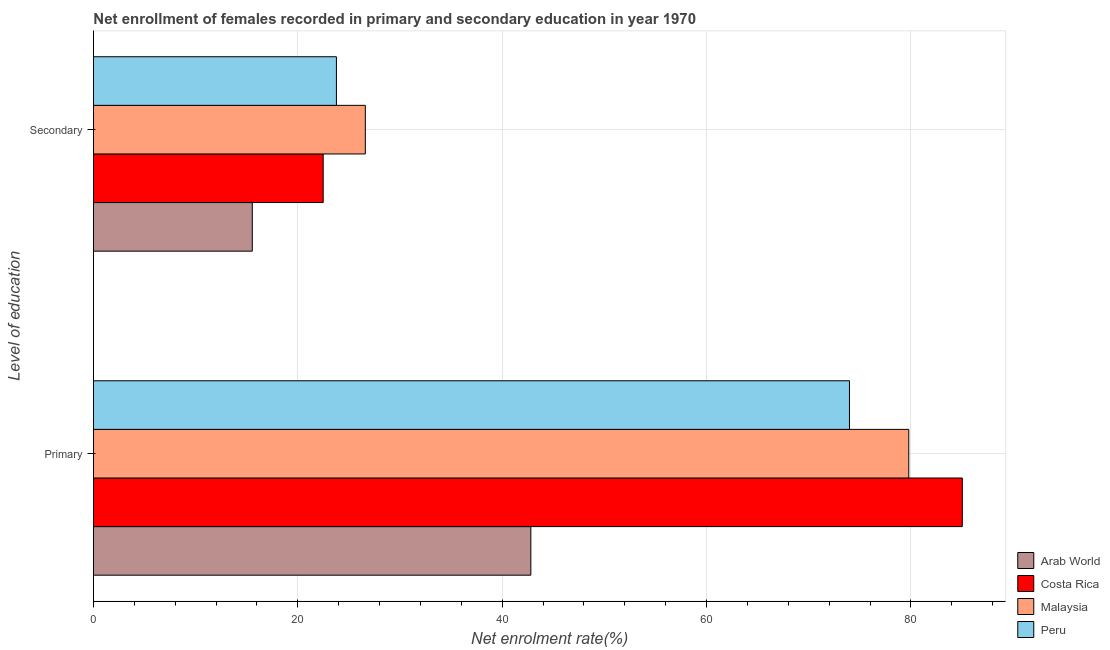Are the number of bars per tick equal to the number of legend labels?
Your response must be concise. Yes. How many bars are there on the 1st tick from the top?
Provide a short and direct response. 4. What is the label of the 2nd group of bars from the top?
Offer a very short reply. Primary. What is the enrollment rate in primary education in Peru?
Your answer should be very brief. 73.99. Across all countries, what is the maximum enrollment rate in secondary education?
Your answer should be very brief. 26.61. Across all countries, what is the minimum enrollment rate in primary education?
Your answer should be very brief. 42.8. In which country was the enrollment rate in primary education minimum?
Ensure brevity in your answer.  Arab World. What is the total enrollment rate in primary education in the graph?
Provide a short and direct response. 281.61. What is the difference between the enrollment rate in secondary education in Malaysia and that in Arab World?
Your response must be concise. 11.06. What is the difference between the enrollment rate in secondary education in Arab World and the enrollment rate in primary education in Peru?
Provide a short and direct response. -58.44. What is the average enrollment rate in primary education per country?
Offer a terse response. 70.4. What is the difference between the enrollment rate in primary education and enrollment rate in secondary education in Malaysia?
Offer a very short reply. 53.18. In how many countries, is the enrollment rate in secondary education greater than 60 %?
Give a very brief answer. 0. What is the ratio of the enrollment rate in secondary education in Peru to that in Arab World?
Your response must be concise. 1.53. What does the 2nd bar from the bottom in Primary represents?
Provide a succinct answer. Costa Rica. How many countries are there in the graph?
Your answer should be compact. 4. Does the graph contain any zero values?
Your answer should be very brief. No. Does the graph contain grids?
Provide a succinct answer. Yes. Where does the legend appear in the graph?
Ensure brevity in your answer.  Bottom right. How many legend labels are there?
Make the answer very short. 4. How are the legend labels stacked?
Your response must be concise. Vertical. What is the title of the graph?
Offer a terse response. Net enrollment of females recorded in primary and secondary education in year 1970. What is the label or title of the X-axis?
Provide a succinct answer. Net enrolment rate(%). What is the label or title of the Y-axis?
Ensure brevity in your answer.  Level of education. What is the Net enrolment rate(%) of Arab World in Primary?
Give a very brief answer. 42.8. What is the Net enrolment rate(%) of Costa Rica in Primary?
Your answer should be compact. 85.03. What is the Net enrolment rate(%) in Malaysia in Primary?
Offer a very short reply. 79.79. What is the Net enrolment rate(%) of Peru in Primary?
Make the answer very short. 73.99. What is the Net enrolment rate(%) of Arab World in Secondary?
Ensure brevity in your answer.  15.54. What is the Net enrolment rate(%) in Costa Rica in Secondary?
Keep it short and to the point. 22.48. What is the Net enrolment rate(%) in Malaysia in Secondary?
Your answer should be compact. 26.61. What is the Net enrolment rate(%) of Peru in Secondary?
Provide a short and direct response. 23.78. Across all Level of education, what is the maximum Net enrolment rate(%) in Arab World?
Ensure brevity in your answer.  42.8. Across all Level of education, what is the maximum Net enrolment rate(%) in Costa Rica?
Your response must be concise. 85.03. Across all Level of education, what is the maximum Net enrolment rate(%) in Malaysia?
Offer a very short reply. 79.79. Across all Level of education, what is the maximum Net enrolment rate(%) in Peru?
Your answer should be very brief. 73.99. Across all Level of education, what is the minimum Net enrolment rate(%) in Arab World?
Give a very brief answer. 15.54. Across all Level of education, what is the minimum Net enrolment rate(%) in Costa Rica?
Ensure brevity in your answer.  22.48. Across all Level of education, what is the minimum Net enrolment rate(%) in Malaysia?
Ensure brevity in your answer.  26.61. Across all Level of education, what is the minimum Net enrolment rate(%) of Peru?
Provide a short and direct response. 23.78. What is the total Net enrolment rate(%) in Arab World in the graph?
Provide a short and direct response. 58.35. What is the total Net enrolment rate(%) in Costa Rica in the graph?
Ensure brevity in your answer.  107.51. What is the total Net enrolment rate(%) of Malaysia in the graph?
Provide a succinct answer. 106.4. What is the total Net enrolment rate(%) of Peru in the graph?
Provide a succinct answer. 97.77. What is the difference between the Net enrolment rate(%) in Arab World in Primary and that in Secondary?
Keep it short and to the point. 27.26. What is the difference between the Net enrolment rate(%) in Costa Rica in Primary and that in Secondary?
Make the answer very short. 62.55. What is the difference between the Net enrolment rate(%) in Malaysia in Primary and that in Secondary?
Your response must be concise. 53.18. What is the difference between the Net enrolment rate(%) of Peru in Primary and that in Secondary?
Offer a very short reply. 50.21. What is the difference between the Net enrolment rate(%) of Arab World in Primary and the Net enrolment rate(%) of Costa Rica in Secondary?
Ensure brevity in your answer.  20.32. What is the difference between the Net enrolment rate(%) of Arab World in Primary and the Net enrolment rate(%) of Malaysia in Secondary?
Provide a succinct answer. 16.2. What is the difference between the Net enrolment rate(%) in Arab World in Primary and the Net enrolment rate(%) in Peru in Secondary?
Provide a succinct answer. 19.03. What is the difference between the Net enrolment rate(%) of Costa Rica in Primary and the Net enrolment rate(%) of Malaysia in Secondary?
Make the answer very short. 58.42. What is the difference between the Net enrolment rate(%) of Costa Rica in Primary and the Net enrolment rate(%) of Peru in Secondary?
Your answer should be very brief. 61.25. What is the difference between the Net enrolment rate(%) in Malaysia in Primary and the Net enrolment rate(%) in Peru in Secondary?
Keep it short and to the point. 56.01. What is the average Net enrolment rate(%) of Arab World per Level of education?
Your answer should be very brief. 29.17. What is the average Net enrolment rate(%) of Costa Rica per Level of education?
Offer a very short reply. 53.76. What is the average Net enrolment rate(%) of Malaysia per Level of education?
Make the answer very short. 53.2. What is the average Net enrolment rate(%) in Peru per Level of education?
Give a very brief answer. 48.88. What is the difference between the Net enrolment rate(%) of Arab World and Net enrolment rate(%) of Costa Rica in Primary?
Give a very brief answer. -42.23. What is the difference between the Net enrolment rate(%) in Arab World and Net enrolment rate(%) in Malaysia in Primary?
Your answer should be compact. -36.99. What is the difference between the Net enrolment rate(%) of Arab World and Net enrolment rate(%) of Peru in Primary?
Keep it short and to the point. -31.18. What is the difference between the Net enrolment rate(%) of Costa Rica and Net enrolment rate(%) of Malaysia in Primary?
Your response must be concise. 5.24. What is the difference between the Net enrolment rate(%) of Costa Rica and Net enrolment rate(%) of Peru in Primary?
Make the answer very short. 11.04. What is the difference between the Net enrolment rate(%) in Malaysia and Net enrolment rate(%) in Peru in Primary?
Provide a succinct answer. 5.8. What is the difference between the Net enrolment rate(%) of Arab World and Net enrolment rate(%) of Costa Rica in Secondary?
Give a very brief answer. -6.94. What is the difference between the Net enrolment rate(%) in Arab World and Net enrolment rate(%) in Malaysia in Secondary?
Make the answer very short. -11.06. What is the difference between the Net enrolment rate(%) in Arab World and Net enrolment rate(%) in Peru in Secondary?
Ensure brevity in your answer.  -8.23. What is the difference between the Net enrolment rate(%) of Costa Rica and Net enrolment rate(%) of Malaysia in Secondary?
Provide a succinct answer. -4.12. What is the difference between the Net enrolment rate(%) of Costa Rica and Net enrolment rate(%) of Peru in Secondary?
Offer a very short reply. -1.3. What is the difference between the Net enrolment rate(%) of Malaysia and Net enrolment rate(%) of Peru in Secondary?
Ensure brevity in your answer.  2.83. What is the ratio of the Net enrolment rate(%) in Arab World in Primary to that in Secondary?
Give a very brief answer. 2.75. What is the ratio of the Net enrolment rate(%) of Costa Rica in Primary to that in Secondary?
Offer a very short reply. 3.78. What is the ratio of the Net enrolment rate(%) of Malaysia in Primary to that in Secondary?
Your answer should be compact. 3. What is the ratio of the Net enrolment rate(%) in Peru in Primary to that in Secondary?
Make the answer very short. 3.11. What is the difference between the highest and the second highest Net enrolment rate(%) of Arab World?
Ensure brevity in your answer.  27.26. What is the difference between the highest and the second highest Net enrolment rate(%) in Costa Rica?
Offer a terse response. 62.55. What is the difference between the highest and the second highest Net enrolment rate(%) of Malaysia?
Provide a succinct answer. 53.18. What is the difference between the highest and the second highest Net enrolment rate(%) of Peru?
Your answer should be very brief. 50.21. What is the difference between the highest and the lowest Net enrolment rate(%) in Arab World?
Offer a terse response. 27.26. What is the difference between the highest and the lowest Net enrolment rate(%) of Costa Rica?
Make the answer very short. 62.55. What is the difference between the highest and the lowest Net enrolment rate(%) in Malaysia?
Ensure brevity in your answer.  53.18. What is the difference between the highest and the lowest Net enrolment rate(%) in Peru?
Offer a terse response. 50.21. 